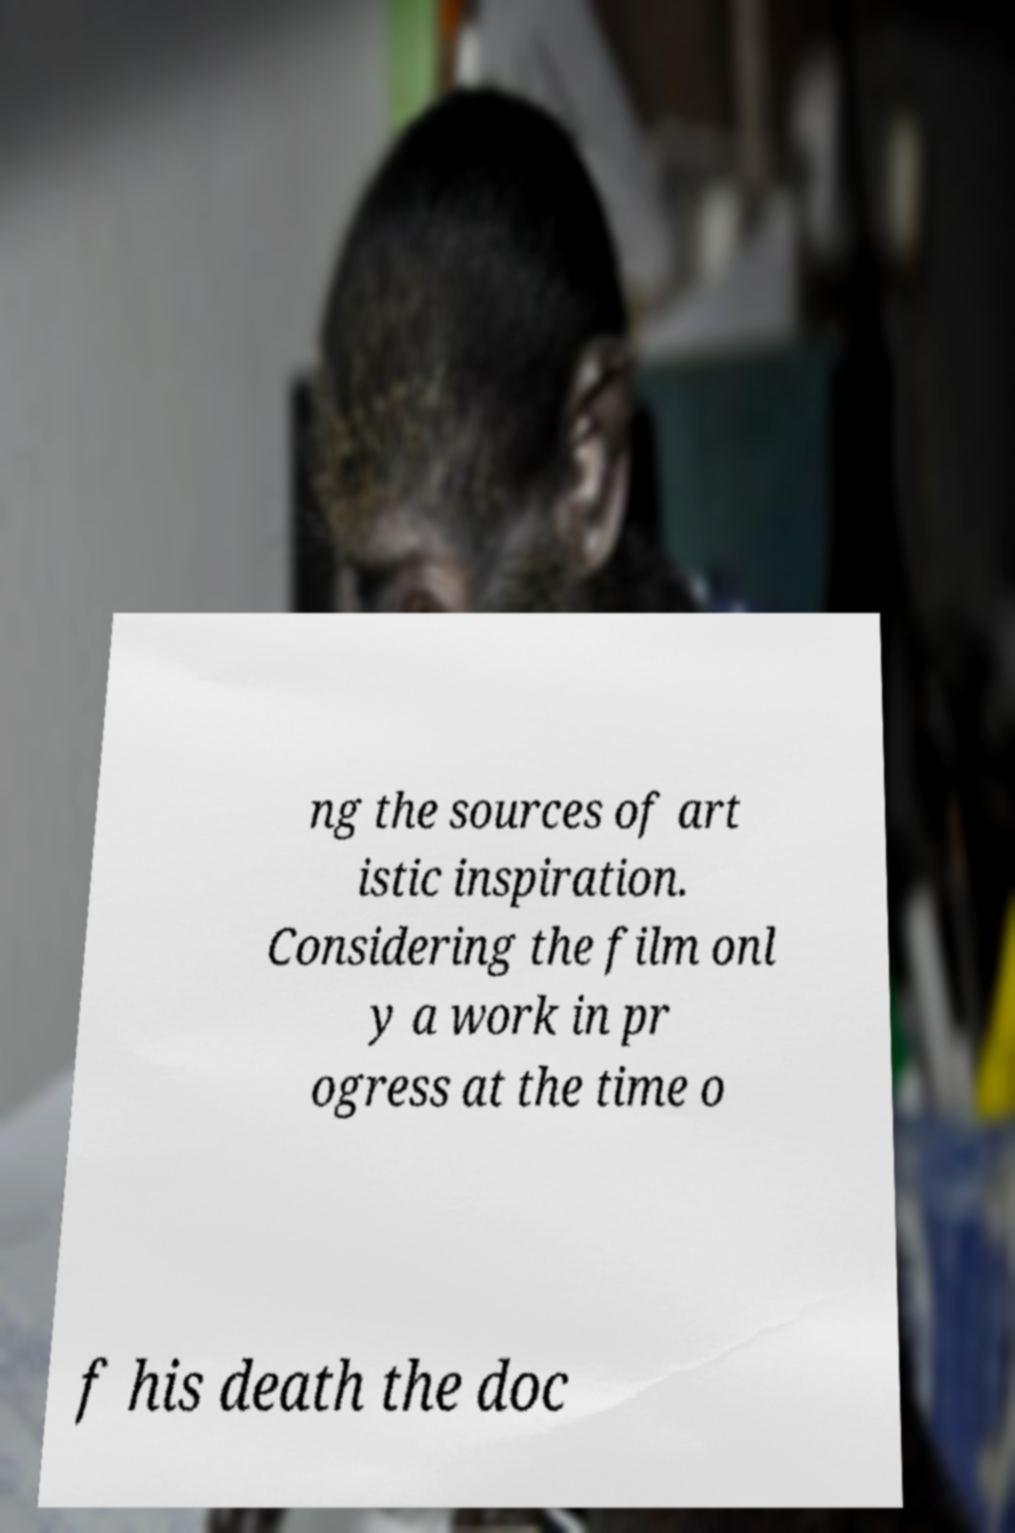Please identify and transcribe the text found in this image. ng the sources of art istic inspiration. Considering the film onl y a work in pr ogress at the time o f his death the doc 